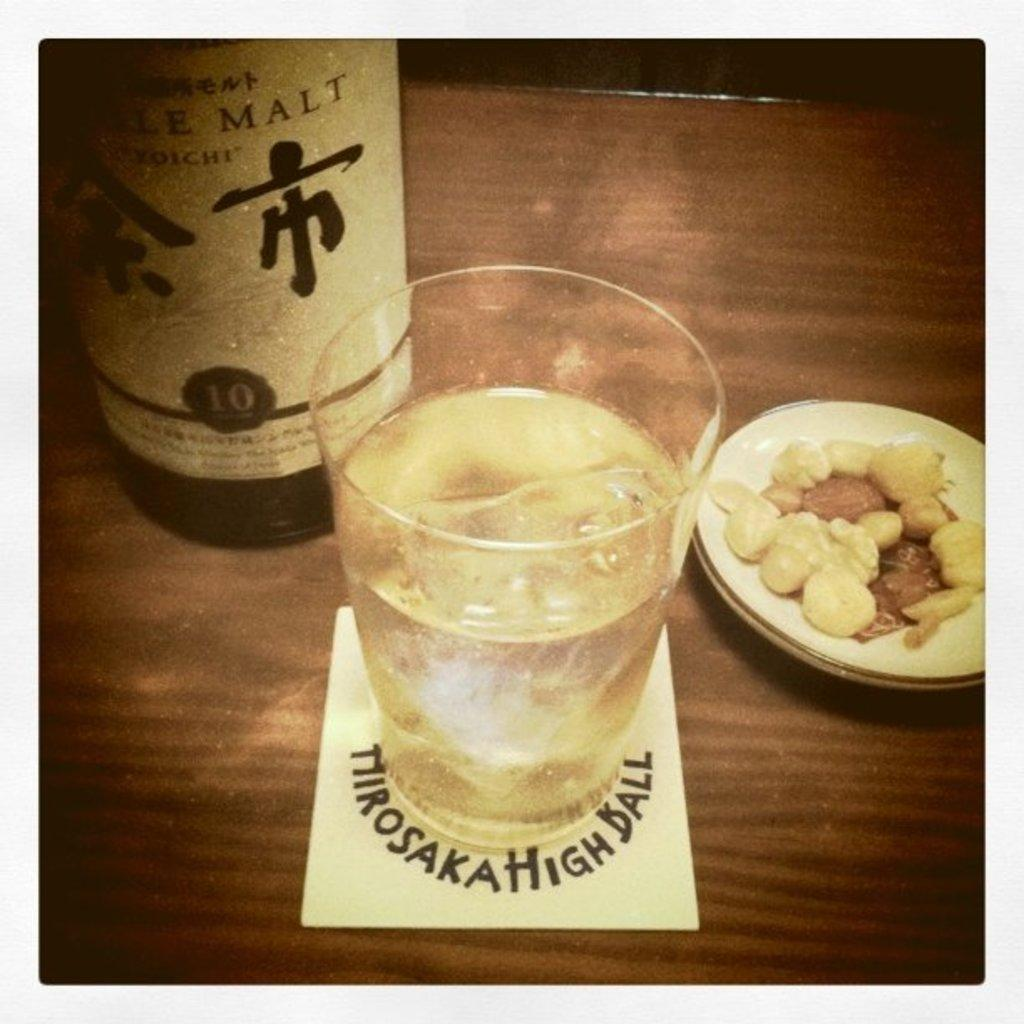<image>
Offer a succinct explanation of the picture presented. A glass sits on a Mirosaka High Ball coaster. 